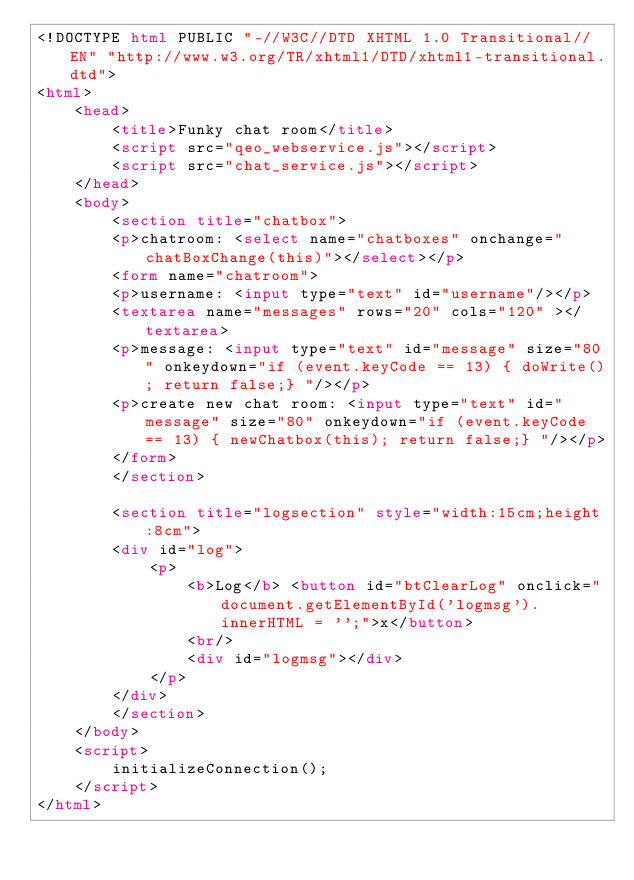<code> <loc_0><loc_0><loc_500><loc_500><_HTML_><!DOCTYPE html PUBLIC "-//W3C//DTD XHTML 1.0 Transitional//EN" "http://www.w3.org/TR/xhtml1/DTD/xhtml1-transitional.dtd">
<html>
    <head>
        <title>Funky chat room</title>
        <script src="qeo_webservice.js"></script>
        <script src="chat_service.js"></script>
    </head>
    <body>
        <section title="chatbox">
        <p>chatroom: <select name="chatboxes" onchange="chatBoxChange(this)"></select></p>
        <form name="chatroom">
        <p>username: <input type="text" id="username"/></p>
        <textarea name="messages" rows="20" cols="120" ></textarea>
        <p>message: <input type="text" id="message" size="80" onkeydown="if (event.keyCode == 13) { doWrite(); return false;} "/></p>
        <p>create new chat room: <input type="text" id="message" size="80" onkeydown="if (event.keyCode == 13) { newChatbox(this); return false;} "/></p>
        </form>
        </section>
        
        <section title="logsection" style="width:15cm;height:8cm">
        <div id="log">
            <p>
                <b>Log</b> <button id="btClearLog" onclick="document.getElementById('logmsg').innerHTML = '';">x</button>                
                <br/>
                <div id="logmsg"></div>
            </p>
        </div>
        </section>
    </body>
    <script>
        initializeConnection();
    </script>
</html>
</code> 